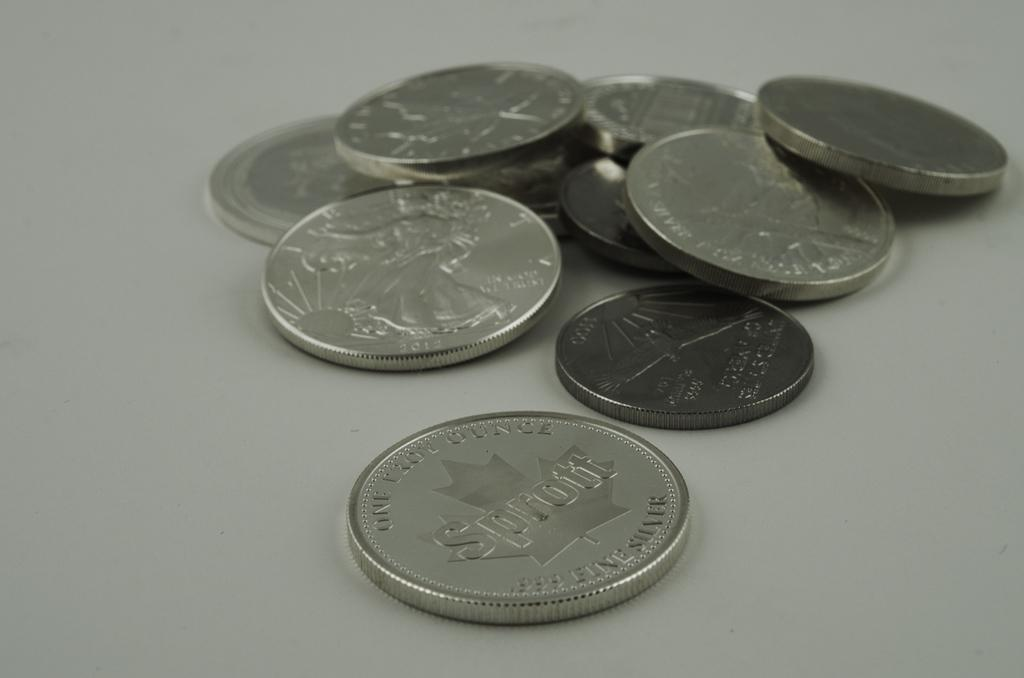<image>
Present a compact description of the photo's key features. A coin in front of other coins has the word Sprott on it. 